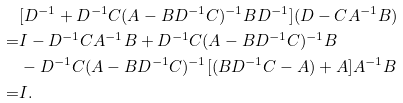Convert formula to latex. <formula><loc_0><loc_0><loc_500><loc_500>& [ D ^ { - 1 } + D ^ { - 1 } C ( A - B D ^ { - 1 } C ) ^ { - 1 } B D ^ { - 1 } ] ( D - C A ^ { - 1 } B ) \\ = & I - D ^ { - 1 } C A ^ { - 1 } B + D ^ { - 1 } C ( A - B D ^ { - 1 } C ) ^ { - 1 } B \\ & - D ^ { - 1 } C ( A - B D ^ { - 1 } C ) ^ { - 1 } [ ( B D ^ { - 1 } C - A ) + A ] A ^ { - 1 } B \\ = & I .</formula> 